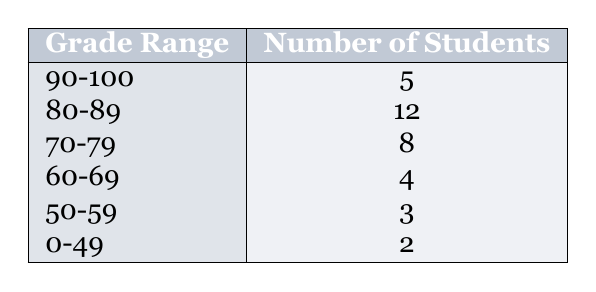What is the highest number of students in any grade range? The table shows the number of students for each grade range. By observing the values, the highest value listed is 12 students in the grade range 80-89.
Answer: 12 How many students received grades below 60? To find the total number of students who received grades below 60, we need to combine the number of students in the grade ranges 50-59 (3 students) and 0-49 (2 students), which equals 3 + 2 = 5 students.
Answer: 5 What percentage of students received grades in the range of 90-100? First, we need to find the total number of students by adding all the numbers: 5 + 12 + 8 + 4 + 3 + 2 = 34. The percentage for the 90-100 range is (5/34) * 100, which equals approximately 14.71%.
Answer: 14.71% Is there a grade range with no students? By analyzing the table, all grade ranges have at least one student, so there are no ranges with zero students.
Answer: No What is the average number of students per grade range? We first find the total number of students, which is 34. There are 6 grade ranges. To find the average, we divide the total number of students (34) by the number of grade ranges (6): 34/6 = 5.67 (approximately).
Answer: 5.67 How many more students are in the 80-89 range compared to the 60-69 range? The number of students in the 80-89 range is 12, and in the 60-69 range is 4. To find the difference, we subtract: 12 - 4 = 8.
Answer: 8 What is the total number of students that received grades of 70 or above? To find this, we add the numbers from the grade ranges 70-79, 80-89, and 90-100, which are 8, 12, and 5 respectively. So, 8 + 12 + 5 = 25 students received grades of 70 or above.
Answer: 25 Which grade range has the least number of students? By reviewing the table, the grade range with the least number of students is 0-49, with 2 students.
Answer: 0-49 How many students scored between 60 and 89? To determine this, we add the number of students in the ranges 60-69 (4 students) and 70-79 (8 students), as well as those in 80-89 (12 students) together: 4 + 8 + 12 = 24 students.
Answer: 24 